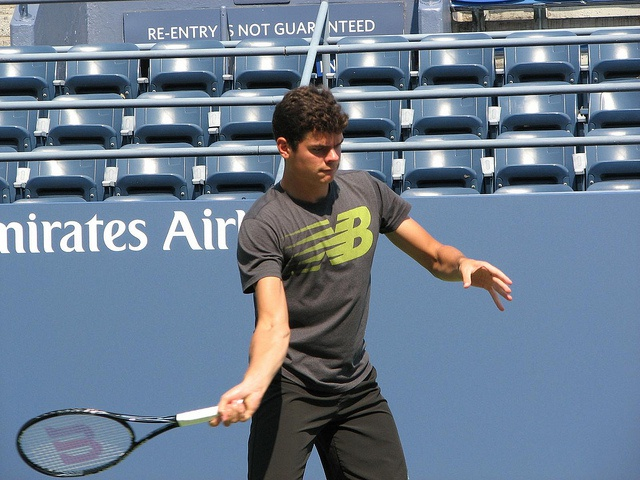Describe the objects in this image and their specific colors. I can see people in darkgray, black, and gray tones, chair in darkgray, gray, lightgray, and black tones, tennis racket in darkgray, gray, and black tones, chair in darkgray, black, gray, and lightgray tones, and chair in darkgray, black, gray, and lightgray tones in this image. 